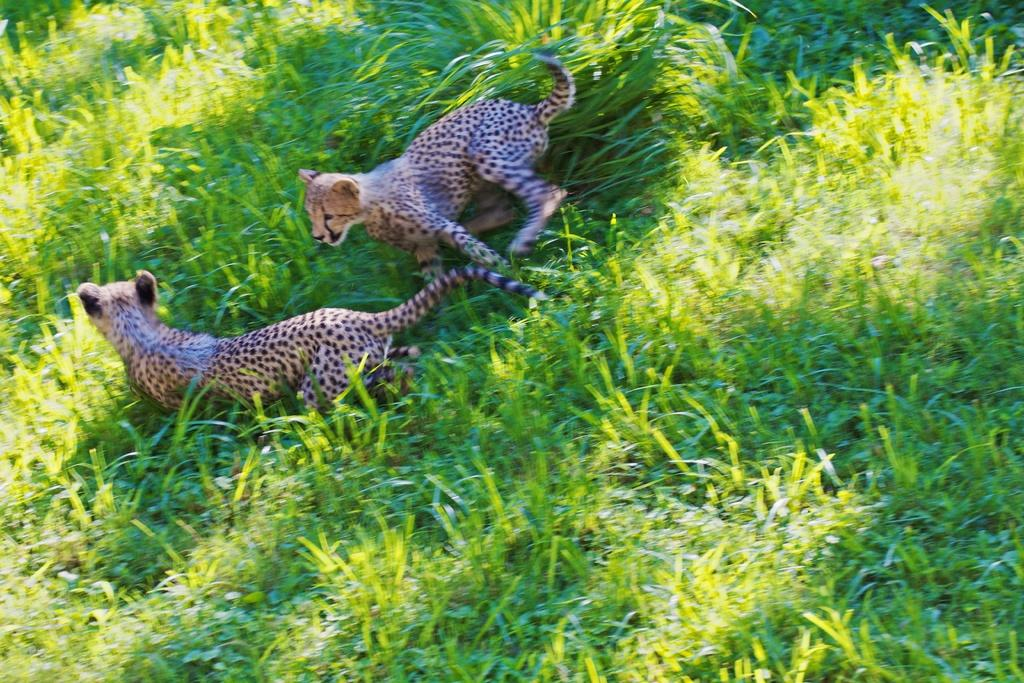What animals can be seen in the image? There are leopards in the image. What type of vegetation is visible in the image? There is grass visible in the image. What reason did the leopards give for going on holiday in the image? There is no indication in the image that the leopards are going on holiday or have any reason for their actions. 